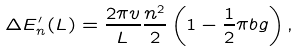Convert formula to latex. <formula><loc_0><loc_0><loc_500><loc_500>\Delta E ^ { \prime } _ { n } ( L ) = \frac { 2 \pi v } { L } \frac { n ^ { 2 } } { 2 } \left ( 1 - \frac { 1 } { 2 } \pi b g \right ) ,</formula> 